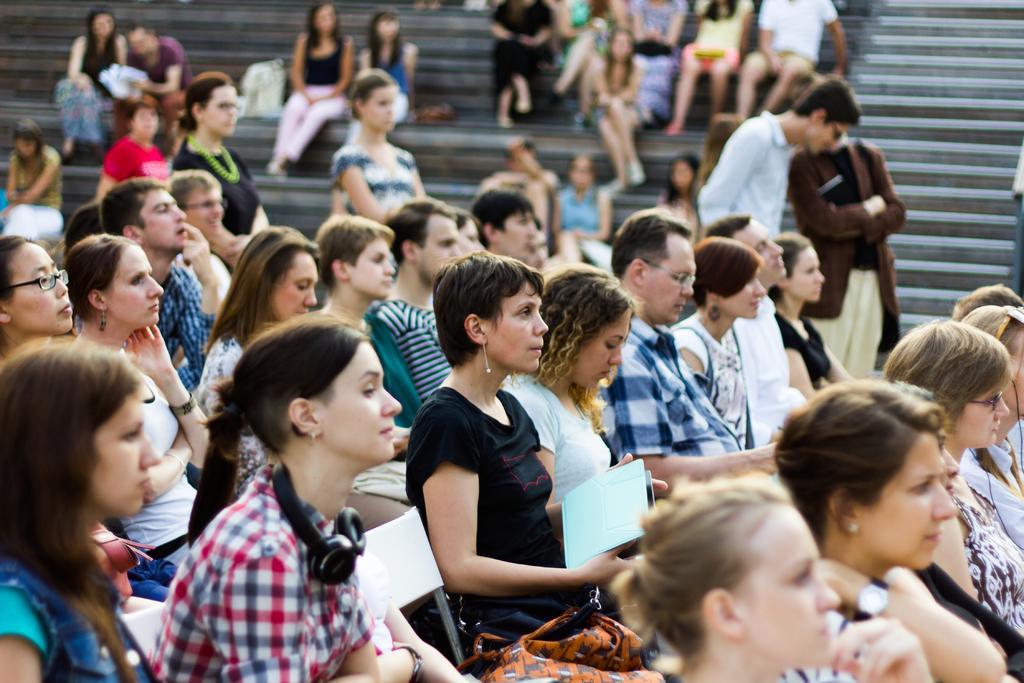How would you summarize this image in a sentence or two? In the center of the image we can see a group of people are sitting on the chairs. In the background of the image we can see some persons are sitting on the stairs and we can see bags, books. In the middle of the image a lady is sitting and holding a book. 